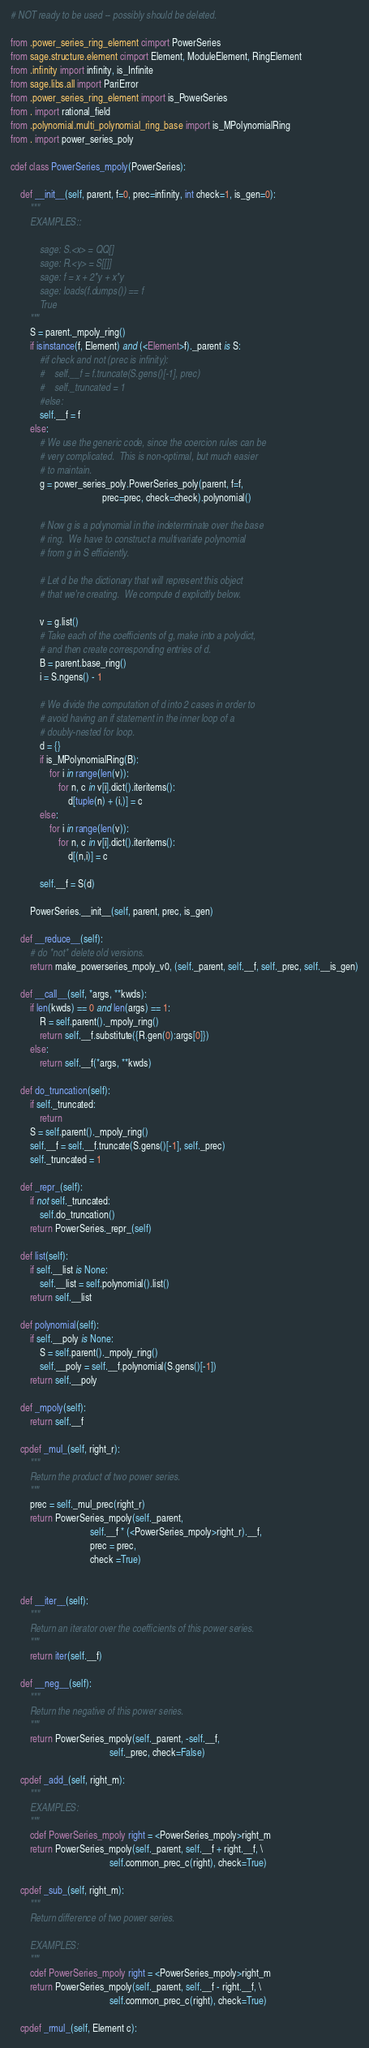<code> <loc_0><loc_0><loc_500><loc_500><_Cython_># NOT ready to be used -- possibly should be deleted.

from .power_series_ring_element cimport PowerSeries
from sage.structure.element cimport Element, ModuleElement, RingElement
from .infinity import infinity, is_Infinite
from sage.libs.all import PariError
from .power_series_ring_element import is_PowerSeries
from . import rational_field
from .polynomial.multi_polynomial_ring_base import is_MPolynomialRing
from . import power_series_poly

cdef class PowerSeries_mpoly(PowerSeries):

    def __init__(self, parent, f=0, prec=infinity, int check=1, is_gen=0):
        """
        EXAMPLES::

            sage: S.<x> = QQ[]
            sage: R.<y> = S[[]]
            sage: f = x + 2*y + x*y
            sage: loads(f.dumps()) == f
            True
        """
        S = parent._mpoly_ring()
        if isinstance(f, Element) and (<Element>f)._parent is S:
            #if check and not (prec is infinity):
            #    self.__f = f.truncate(S.gens()[-1], prec)
            #    self._truncated = 1
            #else:
            self.__f = f
        else:
            # We use the generic code, since the coercion rules can be
            # very complicated.  This is non-optimal, but much easier
            # to maintain.
            g = power_series_poly.PowerSeries_poly(parent, f=f,
                                      prec=prec, check=check).polynomial()

            # Now g is a polynomial in the indeterminate over the base
            # ring.  We have to construct a multivariate polynomial
            # from g in S efficiently.

            # Let d be the dictionary that will represent this object
            # that we're creating.  We compute d explicitly below.

            v = g.list()
            # Take each of the coefficients of g, make into a polydict,
            # and then create corresponding entries of d.
            B = parent.base_ring()
            i = S.ngens() - 1

            # We divide the computation of d into 2 cases in order to
            # avoid having an if statement in the inner loop of a
            # doubly-nested for loop.
            d = {}
            if is_MPolynomialRing(B):
                for i in range(len(v)):
                    for n, c in v[i].dict().iteritems():
                        d[tuple(n) + (i,)] = c
            else:
                for i in range(len(v)):
                    for n, c in v[i].dict().iteritems():
                        d[(n,i)] = c

            self.__f = S(d)

        PowerSeries.__init__(self, parent, prec, is_gen)

    def __reduce__(self):
        # do *not* delete old versions.
        return make_powerseries_mpoly_v0, (self._parent, self.__f, self._prec, self.__is_gen)

    def __call__(self, *args, **kwds):
        if len(kwds) == 0 and len(args) == 1:
            R = self.parent()._mpoly_ring()
            return self.__f.substitute({R.gen(0):args[0]})
        else:
            return self.__f(*args, **kwds)

    def do_truncation(self):
        if self._truncated:
            return
        S = self.parent()._mpoly_ring()
        self.__f = self.__f.truncate(S.gens()[-1], self._prec)
        self._truncated = 1

    def _repr_(self):
        if not self._truncated:
            self.do_truncation()
        return PowerSeries._repr_(self)

    def list(self):
        if self.__list is None:
            self.__list = self.polynomial().list()
        return self.__list

    def polynomial(self):
        if self.__poly is None:
            S = self.parent()._mpoly_ring()
            self.__poly = self.__f.polynomial(S.gens()[-1])
        return self.__poly

    def _mpoly(self):
        return self.__f

    cpdef _mul_(self, right_r):
        """
        Return the product of two power series.
        """
        prec = self._mul_prec(right_r)
        return PowerSeries_mpoly(self._parent,
                                 self.__f * (<PowerSeries_mpoly>right_r).__f,
                                 prec = prec,
                                 check =True)


    def __iter__(self):
        """
        Return an iterator over the coefficients of this power series.
        """
        return iter(self.__f)

    def __neg__(self):
        """
        Return the negative of this power series.
        """
        return PowerSeries_mpoly(self._parent, -self.__f,
                                         self._prec, check=False)

    cpdef _add_(self, right_m):
        """
        EXAMPLES:
        """
        cdef PowerSeries_mpoly right = <PowerSeries_mpoly>right_m
        return PowerSeries_mpoly(self._parent, self.__f + right.__f, \
                                         self.common_prec_c(right), check=True)

    cpdef _sub_(self, right_m):
        """
        Return difference of two power series.

        EXAMPLES:
        """
        cdef PowerSeries_mpoly right = <PowerSeries_mpoly>right_m
        return PowerSeries_mpoly(self._parent, self.__f - right.__f, \
                                         self.common_prec_c(right), check=True)

    cpdef _rmul_(self, Element c):</code> 